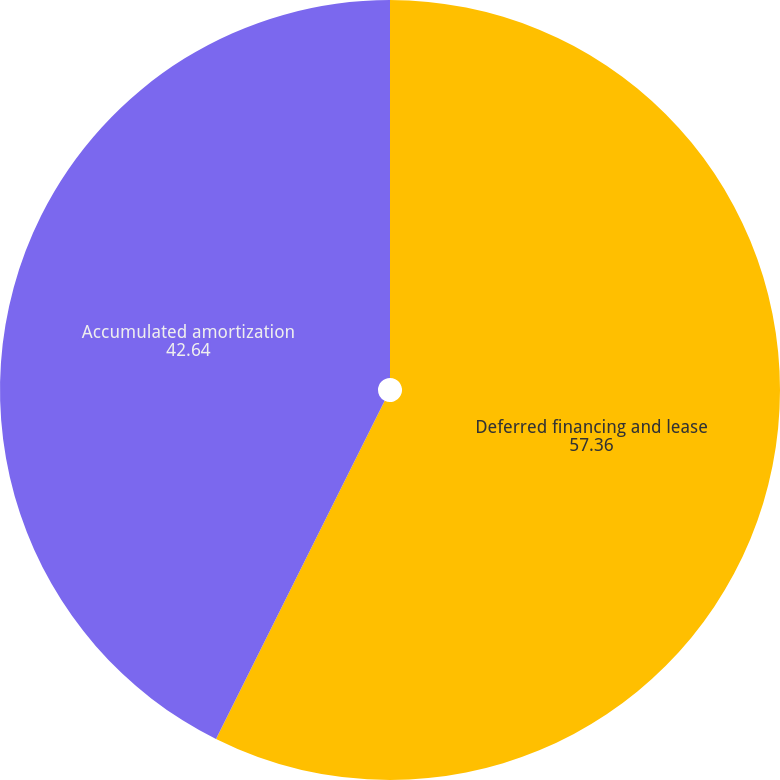<chart> <loc_0><loc_0><loc_500><loc_500><pie_chart><fcel>Deferred financing and lease<fcel>Accumulated amortization<nl><fcel>57.36%<fcel>42.64%<nl></chart> 